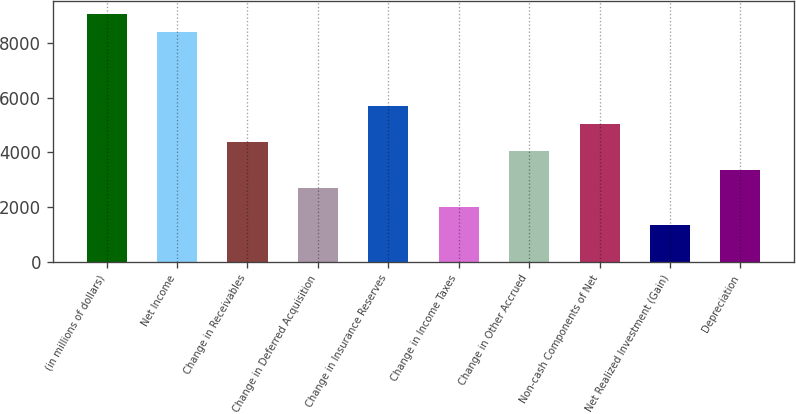Convert chart to OTSL. <chart><loc_0><loc_0><loc_500><loc_500><bar_chart><fcel>(in millions of dollars)<fcel>Net Income<fcel>Change in Receivables<fcel>Change in Deferred Acquisition<fcel>Change in Insurance Reserves<fcel>Change in Income Taxes<fcel>Change in Other Accrued<fcel>Non-cash Components of Net<fcel>Net Realized Investment (Gain)<fcel>Depreciation<nl><fcel>9068.85<fcel>8397.55<fcel>4369.75<fcel>2691.5<fcel>5712.35<fcel>2020.2<fcel>4034.1<fcel>5041.05<fcel>1348.9<fcel>3362.8<nl></chart> 